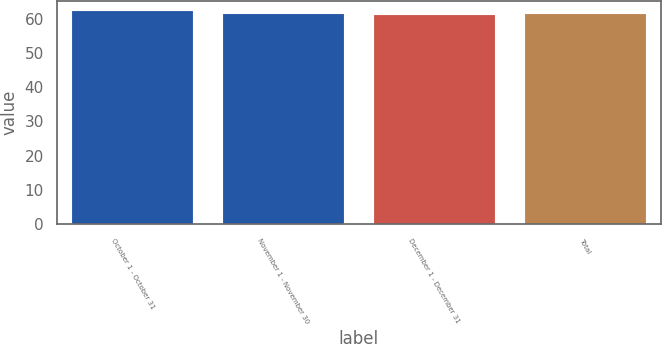Convert chart. <chart><loc_0><loc_0><loc_500><loc_500><bar_chart><fcel>October 1 - October 31<fcel>November 1 - November 30<fcel>December 1 - December 31<fcel>Total<nl><fcel>62.17<fcel>61.39<fcel>60.96<fcel>61.51<nl></chart> 